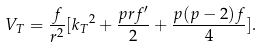<formula> <loc_0><loc_0><loc_500><loc_500>V _ { T } = \frac { f } { r ^ { 2 } } [ { k _ { T } } ^ { 2 } + \frac { p r f ^ { \prime } } { 2 } + \frac { p ( p - 2 ) f } { 4 } ] .</formula> 